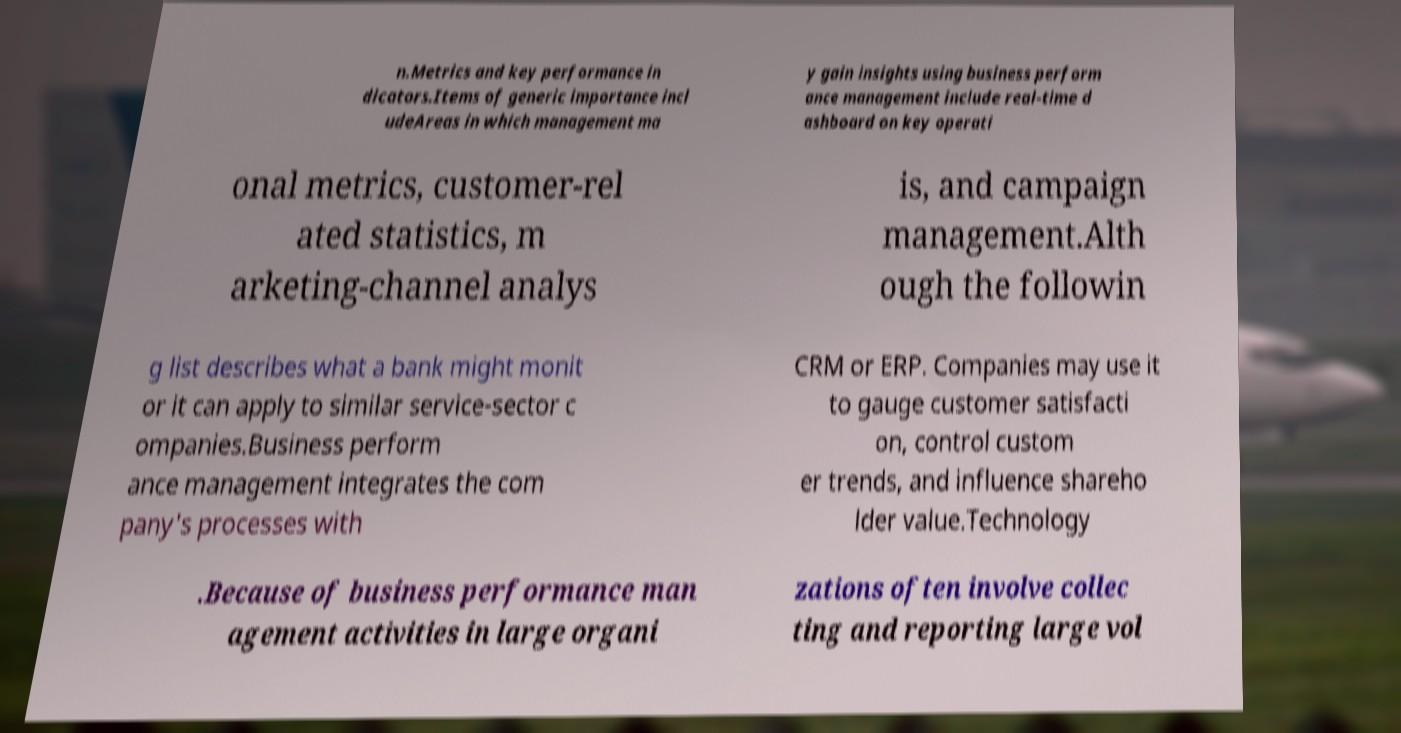Please read and relay the text visible in this image. What does it say? n.Metrics and key performance in dicators.Items of generic importance incl udeAreas in which management ma y gain insights using business perform ance management include real-time d ashboard on key operati onal metrics, customer-rel ated statistics, m arketing-channel analys is, and campaign management.Alth ough the followin g list describes what a bank might monit or it can apply to similar service-sector c ompanies.Business perform ance management integrates the com pany's processes with CRM or ERP. Companies may use it to gauge customer satisfacti on, control custom er trends, and influence shareho lder value.Technology .Because of business performance man agement activities in large organi zations often involve collec ting and reporting large vol 